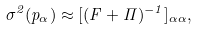Convert formula to latex. <formula><loc_0><loc_0><loc_500><loc_500>\sigma ^ { 2 } ( p _ { \alpha } ) \approx [ ( { F } + \Pi ) ^ { - 1 } ] _ { \alpha \alpha } ,</formula> 